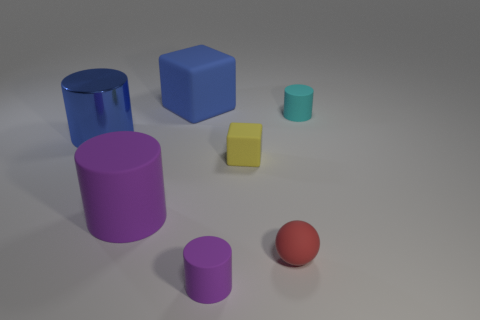Is there anything else that has the same size as the yellow rubber cube?
Offer a very short reply. Yes. Does the big object behind the blue cylinder have the same color as the metal cylinder?
Offer a terse response. Yes. The shiny cylinder has what size?
Ensure brevity in your answer.  Large. Is the material of the tiny object behind the tiny block the same as the blue cube?
Your response must be concise. Yes. What number of small matte cylinders are there?
Provide a succinct answer. 2. How many objects are matte blocks or blue metallic cylinders?
Your response must be concise. 3. There is a purple rubber thing in front of the red thing that is right of the blue cylinder; how many purple objects are behind it?
Offer a very short reply. 1. Is there anything else of the same color as the small rubber ball?
Give a very brief answer. No. Is the color of the big cylinder that is in front of the small yellow matte block the same as the cylinder in front of the matte ball?
Provide a short and direct response. Yes. Is the number of matte cubes that are on the left side of the ball greater than the number of cyan things that are left of the big metallic cylinder?
Ensure brevity in your answer.  Yes. 